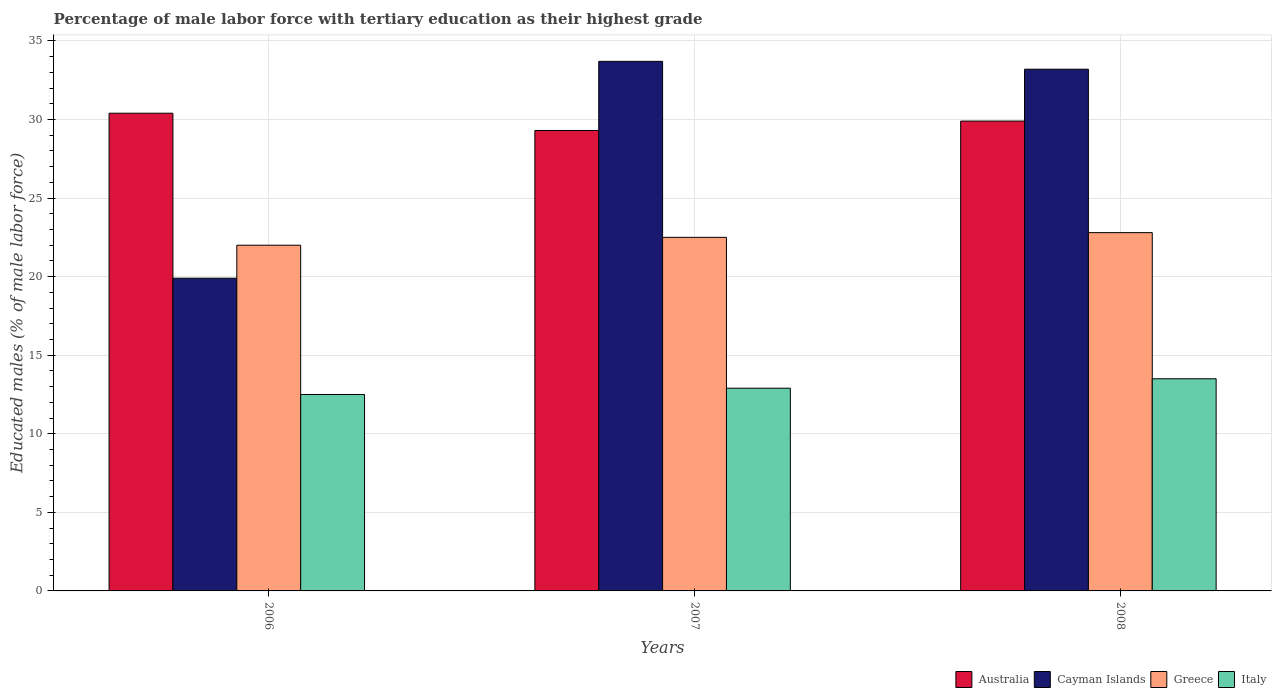How many groups of bars are there?
Your answer should be compact. 3. Are the number of bars per tick equal to the number of legend labels?
Your answer should be very brief. Yes. Are the number of bars on each tick of the X-axis equal?
Make the answer very short. Yes. In how many cases, is the number of bars for a given year not equal to the number of legend labels?
Give a very brief answer. 0. What is the percentage of male labor force with tertiary education in Greece in 2006?
Provide a succinct answer. 22. Across all years, what is the maximum percentage of male labor force with tertiary education in Cayman Islands?
Offer a very short reply. 33.7. Across all years, what is the minimum percentage of male labor force with tertiary education in Australia?
Your answer should be compact. 29.3. In which year was the percentage of male labor force with tertiary education in Cayman Islands minimum?
Offer a very short reply. 2006. What is the total percentage of male labor force with tertiary education in Australia in the graph?
Make the answer very short. 89.6. What is the difference between the percentage of male labor force with tertiary education in Italy in 2007 and the percentage of male labor force with tertiary education in Australia in 2006?
Your response must be concise. -17.5. What is the average percentage of male labor force with tertiary education in Italy per year?
Ensure brevity in your answer.  12.97. In the year 2008, what is the difference between the percentage of male labor force with tertiary education in Greece and percentage of male labor force with tertiary education in Australia?
Ensure brevity in your answer.  -7.1. In how many years, is the percentage of male labor force with tertiary education in Italy greater than 11 %?
Ensure brevity in your answer.  3. What is the ratio of the percentage of male labor force with tertiary education in Australia in 2006 to that in 2008?
Your response must be concise. 1.02. Is the percentage of male labor force with tertiary education in Greece in 2007 less than that in 2008?
Provide a short and direct response. Yes. What is the difference between the highest and the second highest percentage of male labor force with tertiary education in Italy?
Your response must be concise. 0.6. In how many years, is the percentage of male labor force with tertiary education in Cayman Islands greater than the average percentage of male labor force with tertiary education in Cayman Islands taken over all years?
Your response must be concise. 2. Is the sum of the percentage of male labor force with tertiary education in Australia in 2006 and 2008 greater than the maximum percentage of male labor force with tertiary education in Greece across all years?
Make the answer very short. Yes. What does the 3rd bar from the right in 2007 represents?
Give a very brief answer. Cayman Islands. How many bars are there?
Make the answer very short. 12. Are all the bars in the graph horizontal?
Offer a terse response. No. How many years are there in the graph?
Your answer should be very brief. 3. What is the difference between two consecutive major ticks on the Y-axis?
Your answer should be compact. 5. Does the graph contain any zero values?
Your answer should be compact. No. Does the graph contain grids?
Provide a short and direct response. Yes. What is the title of the graph?
Make the answer very short. Percentage of male labor force with tertiary education as their highest grade. Does "Denmark" appear as one of the legend labels in the graph?
Your answer should be very brief. No. What is the label or title of the X-axis?
Keep it short and to the point. Years. What is the label or title of the Y-axis?
Your answer should be compact. Educated males (% of male labor force). What is the Educated males (% of male labor force) in Australia in 2006?
Your answer should be very brief. 30.4. What is the Educated males (% of male labor force) in Cayman Islands in 2006?
Your response must be concise. 19.9. What is the Educated males (% of male labor force) in Australia in 2007?
Ensure brevity in your answer.  29.3. What is the Educated males (% of male labor force) of Cayman Islands in 2007?
Your answer should be compact. 33.7. What is the Educated males (% of male labor force) in Italy in 2007?
Your answer should be compact. 12.9. What is the Educated males (% of male labor force) in Australia in 2008?
Make the answer very short. 29.9. What is the Educated males (% of male labor force) of Cayman Islands in 2008?
Keep it short and to the point. 33.2. What is the Educated males (% of male labor force) of Greece in 2008?
Offer a very short reply. 22.8. Across all years, what is the maximum Educated males (% of male labor force) in Australia?
Ensure brevity in your answer.  30.4. Across all years, what is the maximum Educated males (% of male labor force) of Cayman Islands?
Your answer should be compact. 33.7. Across all years, what is the maximum Educated males (% of male labor force) of Greece?
Offer a very short reply. 22.8. Across all years, what is the maximum Educated males (% of male labor force) of Italy?
Your answer should be very brief. 13.5. Across all years, what is the minimum Educated males (% of male labor force) of Australia?
Offer a very short reply. 29.3. Across all years, what is the minimum Educated males (% of male labor force) in Cayman Islands?
Give a very brief answer. 19.9. Across all years, what is the minimum Educated males (% of male labor force) of Greece?
Your answer should be compact. 22. Across all years, what is the minimum Educated males (% of male labor force) in Italy?
Provide a short and direct response. 12.5. What is the total Educated males (% of male labor force) of Australia in the graph?
Give a very brief answer. 89.6. What is the total Educated males (% of male labor force) of Cayman Islands in the graph?
Your response must be concise. 86.8. What is the total Educated males (% of male labor force) of Greece in the graph?
Make the answer very short. 67.3. What is the total Educated males (% of male labor force) of Italy in the graph?
Give a very brief answer. 38.9. What is the difference between the Educated males (% of male labor force) in Cayman Islands in 2006 and that in 2007?
Ensure brevity in your answer.  -13.8. What is the difference between the Educated males (% of male labor force) of Italy in 2006 and that in 2007?
Ensure brevity in your answer.  -0.4. What is the difference between the Educated males (% of male labor force) of Cayman Islands in 2006 and that in 2008?
Your answer should be very brief. -13.3. What is the difference between the Educated males (% of male labor force) of Australia in 2006 and the Educated males (% of male labor force) of Cayman Islands in 2007?
Make the answer very short. -3.3. What is the difference between the Educated males (% of male labor force) in Australia in 2006 and the Educated males (% of male labor force) in Greece in 2007?
Provide a succinct answer. 7.9. What is the difference between the Educated males (% of male labor force) of Cayman Islands in 2006 and the Educated males (% of male labor force) of Greece in 2007?
Make the answer very short. -2.6. What is the difference between the Educated males (% of male labor force) of Cayman Islands in 2006 and the Educated males (% of male labor force) of Italy in 2007?
Your response must be concise. 7. What is the difference between the Educated males (% of male labor force) in Australia in 2006 and the Educated males (% of male labor force) in Cayman Islands in 2008?
Offer a very short reply. -2.8. What is the difference between the Educated males (% of male labor force) of Australia in 2006 and the Educated males (% of male labor force) of Italy in 2008?
Ensure brevity in your answer.  16.9. What is the difference between the Educated males (% of male labor force) in Cayman Islands in 2006 and the Educated males (% of male labor force) in Greece in 2008?
Your answer should be compact. -2.9. What is the difference between the Educated males (% of male labor force) of Greece in 2006 and the Educated males (% of male labor force) of Italy in 2008?
Offer a terse response. 8.5. What is the difference between the Educated males (% of male labor force) of Australia in 2007 and the Educated males (% of male labor force) of Cayman Islands in 2008?
Your answer should be very brief. -3.9. What is the difference between the Educated males (% of male labor force) of Australia in 2007 and the Educated males (% of male labor force) of Greece in 2008?
Your answer should be compact. 6.5. What is the difference between the Educated males (% of male labor force) of Australia in 2007 and the Educated males (% of male labor force) of Italy in 2008?
Provide a short and direct response. 15.8. What is the difference between the Educated males (% of male labor force) in Cayman Islands in 2007 and the Educated males (% of male labor force) in Italy in 2008?
Your answer should be compact. 20.2. What is the average Educated males (% of male labor force) in Australia per year?
Provide a short and direct response. 29.87. What is the average Educated males (% of male labor force) in Cayman Islands per year?
Ensure brevity in your answer.  28.93. What is the average Educated males (% of male labor force) of Greece per year?
Provide a short and direct response. 22.43. What is the average Educated males (% of male labor force) in Italy per year?
Give a very brief answer. 12.97. In the year 2006, what is the difference between the Educated males (% of male labor force) of Cayman Islands and Educated males (% of male labor force) of Greece?
Give a very brief answer. -2.1. In the year 2006, what is the difference between the Educated males (% of male labor force) of Cayman Islands and Educated males (% of male labor force) of Italy?
Your answer should be compact. 7.4. In the year 2007, what is the difference between the Educated males (% of male labor force) in Australia and Educated males (% of male labor force) in Cayman Islands?
Provide a succinct answer. -4.4. In the year 2007, what is the difference between the Educated males (% of male labor force) of Australia and Educated males (% of male labor force) of Greece?
Keep it short and to the point. 6.8. In the year 2007, what is the difference between the Educated males (% of male labor force) in Cayman Islands and Educated males (% of male labor force) in Italy?
Ensure brevity in your answer.  20.8. In the year 2008, what is the difference between the Educated males (% of male labor force) in Australia and Educated males (% of male labor force) in Cayman Islands?
Give a very brief answer. -3.3. In the year 2008, what is the difference between the Educated males (% of male labor force) of Australia and Educated males (% of male labor force) of Italy?
Your answer should be very brief. 16.4. In the year 2008, what is the difference between the Educated males (% of male labor force) in Cayman Islands and Educated males (% of male labor force) in Italy?
Ensure brevity in your answer.  19.7. What is the ratio of the Educated males (% of male labor force) of Australia in 2006 to that in 2007?
Give a very brief answer. 1.04. What is the ratio of the Educated males (% of male labor force) of Cayman Islands in 2006 to that in 2007?
Make the answer very short. 0.59. What is the ratio of the Educated males (% of male labor force) of Greece in 2006 to that in 2007?
Offer a terse response. 0.98. What is the ratio of the Educated males (% of male labor force) of Italy in 2006 to that in 2007?
Your response must be concise. 0.97. What is the ratio of the Educated males (% of male labor force) in Australia in 2006 to that in 2008?
Offer a very short reply. 1.02. What is the ratio of the Educated males (% of male labor force) of Cayman Islands in 2006 to that in 2008?
Keep it short and to the point. 0.6. What is the ratio of the Educated males (% of male labor force) of Greece in 2006 to that in 2008?
Your answer should be very brief. 0.96. What is the ratio of the Educated males (% of male labor force) in Italy in 2006 to that in 2008?
Your answer should be very brief. 0.93. What is the ratio of the Educated males (% of male labor force) of Australia in 2007 to that in 2008?
Your answer should be very brief. 0.98. What is the ratio of the Educated males (% of male labor force) of Cayman Islands in 2007 to that in 2008?
Offer a terse response. 1.02. What is the ratio of the Educated males (% of male labor force) of Italy in 2007 to that in 2008?
Your answer should be very brief. 0.96. What is the difference between the highest and the second highest Educated males (% of male labor force) of Cayman Islands?
Keep it short and to the point. 0.5. What is the difference between the highest and the lowest Educated males (% of male labor force) in Greece?
Keep it short and to the point. 0.8. What is the difference between the highest and the lowest Educated males (% of male labor force) in Italy?
Provide a short and direct response. 1. 